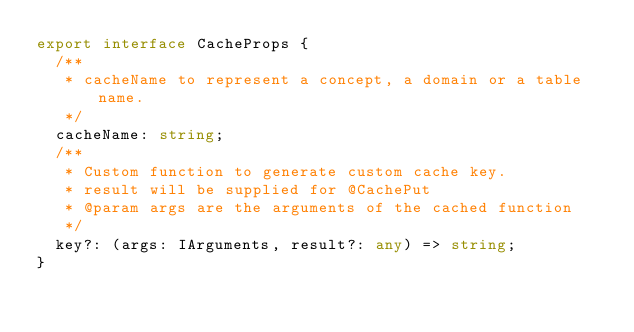<code> <loc_0><loc_0><loc_500><loc_500><_TypeScript_>export interface CacheProps {
  /**
   * cacheName to represent a concept, a domain or a table name.
   */
  cacheName: string;
  /**
   * Custom function to generate custom cache key.
   * result will be supplied for @CachePut
   * @param args are the arguments of the cached function
   */
  key?: (args: IArguments, result?: any) => string;
}
</code> 